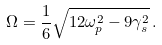Convert formula to latex. <formula><loc_0><loc_0><loc_500><loc_500>\Omega = \frac { 1 } { 6 } \sqrt { 1 2 \omega _ { p } ^ { 2 } - 9 \gamma _ { s } ^ { 2 } } \, .</formula> 